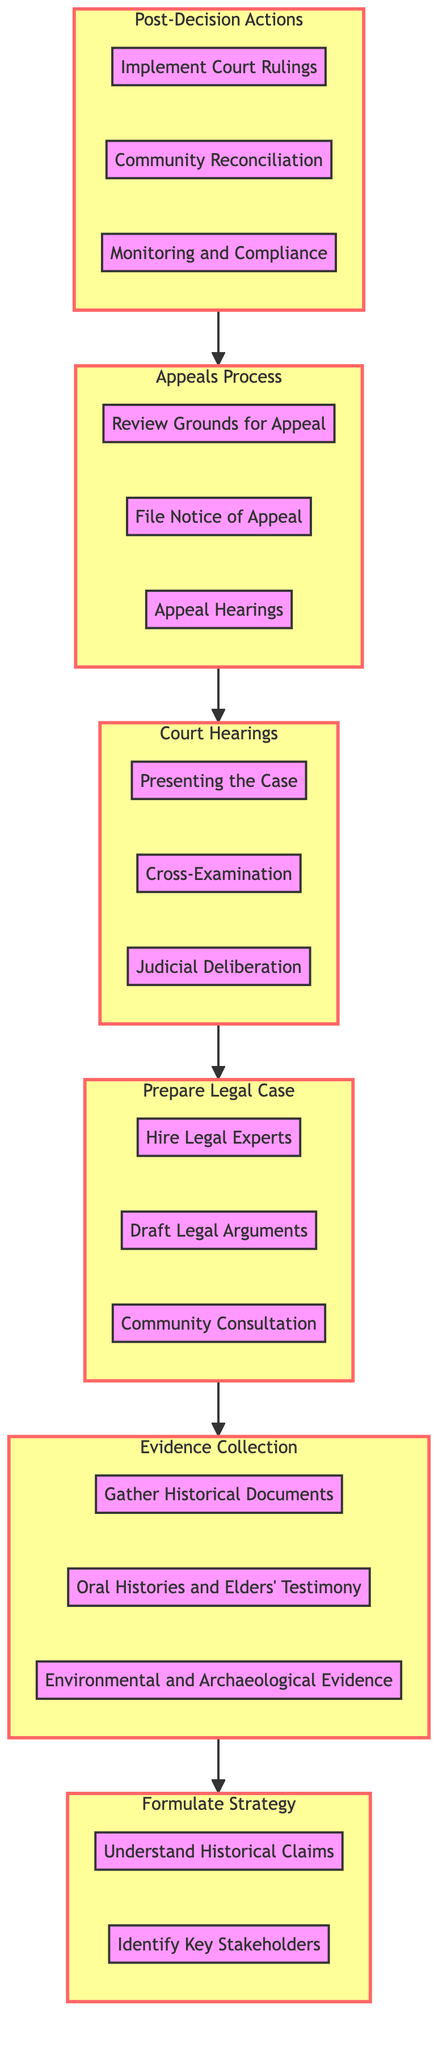What are the last steps after the Court Hearings? The last steps after the Court Hearings are represented by the "Post-Decision Actions" section which includes Implement Court Rulings, Community Reconciliation, and Monitoring and Compliance.
Answer: Post-Decision Actions What comes before Evidence Collection? According to the flow diagram, the step that comes before Evidence Collection is Prepare Legal Case. This indicates the order of actions taken in the process.
Answer: Prepare Legal Case How many steps are in the Appeals Process? The Appeals Process section consists of three steps: Review Grounds for Appeal, File Notice of Appeal, and Appeal Hearings. Therefore, there are a total of three steps.
Answer: 3 What is the first step in the diagram? The first step in the diagram, at the bottom, is Formulate Strategy, which includes the first two steps of the entire process.
Answer: Formulate Strategy Which section follows the Evidence Collection phase? The section that follows the Evidence Collection phase in the flow is Prepare Legal Case, indicating the sequential progression in the process of navigating legal battles.
Answer: Prepare Legal Case What step involves collecting testimonies from elders? The step that involves collecting testimonies from elders is Oral Histories and Elders' Testimony, which is part of the Evidence Collection phase.
Answer: Oral Histories and Elders' Testimony Which step is responsible for hiring legal experts? Hiring legal experts is the first step in the Prepare Legal Case section, emphasizing the importance of legal counsel in the process.
Answer: Hire Legal Experts What leads directly to Judicial Deliberation? Judicial Deliberation is preceded by the Cross-Examination step, which is part of the Court Hearings phase, showing the progression of the legal process.
Answer: Cross-Examination What must be done before filing a Notice of Appeal? Before filing a Notice of Appeal, the grounds for appeal must be reviewed as indicated in the Appeals Process section of the diagram.
Answer: Review Grounds for Appeal 